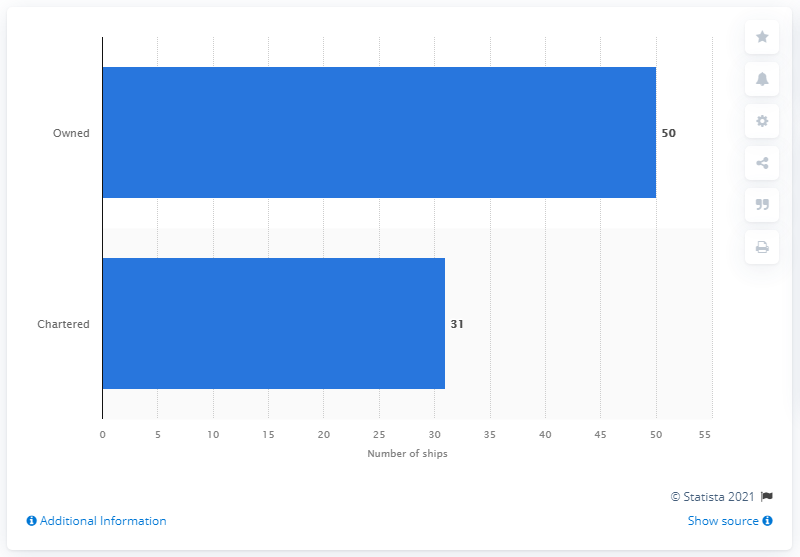Highlight a few significant elements in this photo. 31 out of PIL's ships were chartered. 